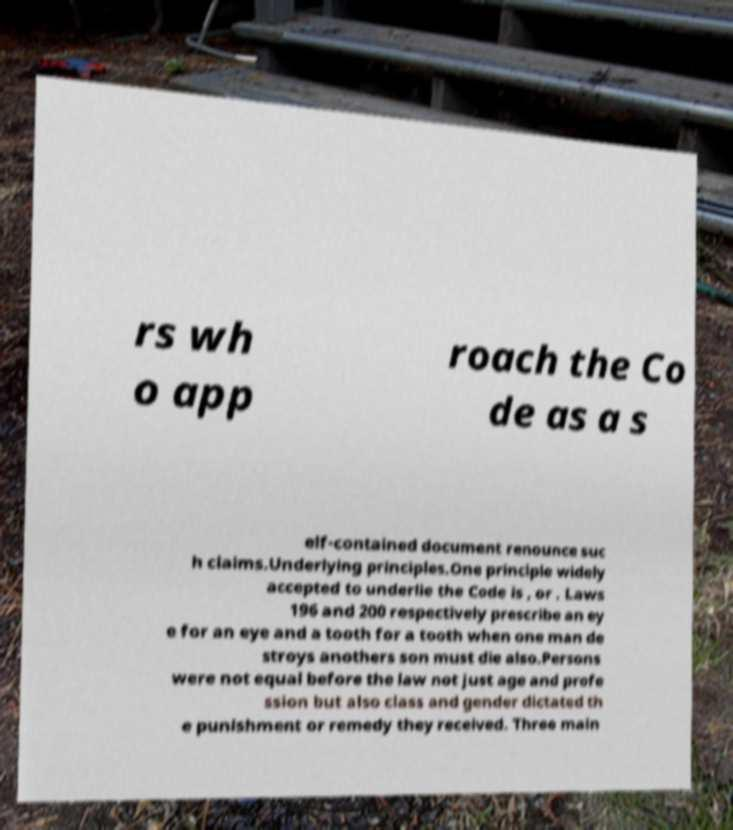Please read and relay the text visible in this image. What does it say? rs wh o app roach the Co de as a s elf-contained document renounce suc h claims.Underlying principles.One principle widely accepted to underlie the Code is , or . Laws 196 and 200 respectively prescribe an ey e for an eye and a tooth for a tooth when one man de stroys anothers son must die also.Persons were not equal before the law not just age and profe ssion but also class and gender dictated th e punishment or remedy they received. Three main 